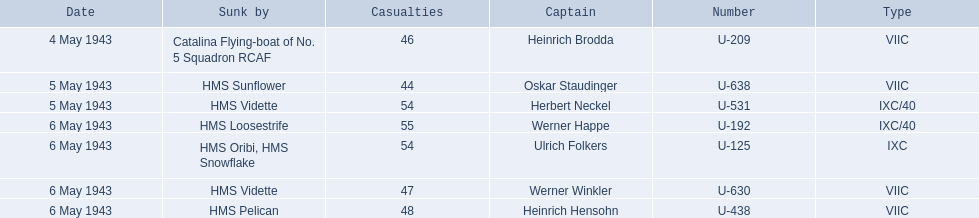Who were the captains in the ons 5 convoy? Heinrich Brodda, Oskar Staudinger, Herbert Neckel, Werner Happe, Ulrich Folkers, Werner Winkler, Heinrich Hensohn. Which ones lost their u-boat on may 5? Oskar Staudinger, Herbert Neckel. Of those, which one is not oskar staudinger? Herbert Neckel. 